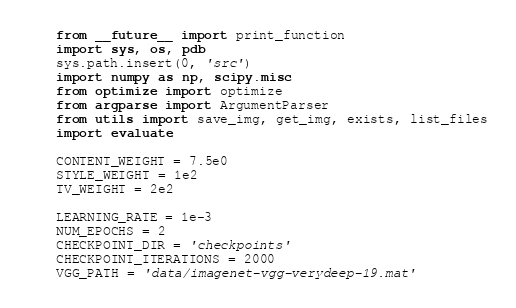<code> <loc_0><loc_0><loc_500><loc_500><_Python_>from __future__ import print_function
import sys, os, pdb
sys.path.insert(0, 'src')
import numpy as np, scipy.misc 
from optimize import optimize
from argparse import ArgumentParser
from utils import save_img, get_img, exists, list_files
import evaluate

CONTENT_WEIGHT = 7.5e0
STYLE_WEIGHT = 1e2
TV_WEIGHT = 2e2

LEARNING_RATE = 1e-3
NUM_EPOCHS = 2
CHECKPOINT_DIR = 'checkpoints'
CHECKPOINT_ITERATIONS = 2000
VGG_PATH = 'data/imagenet-vgg-verydeep-19.mat'</code> 